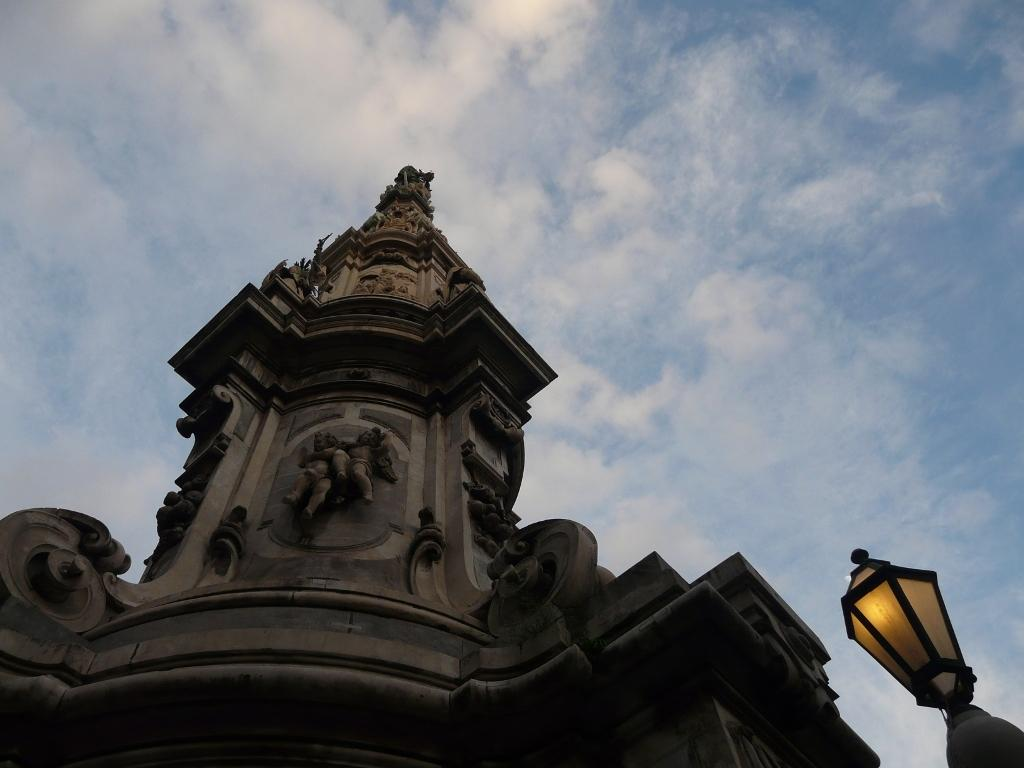What type of structure is present in the image? There is a building in the image. What decorative elements can be seen on the building? The building has sculptures. Can you describe the lighting in the image? There is light in the image. What can be seen in the background of the image? The sky is visible in the background of the image. What type of fuel is required to power the sculptures in the image? There is no information about the sculptures requiring fuel, and the image does not show any sculptures being powered. 